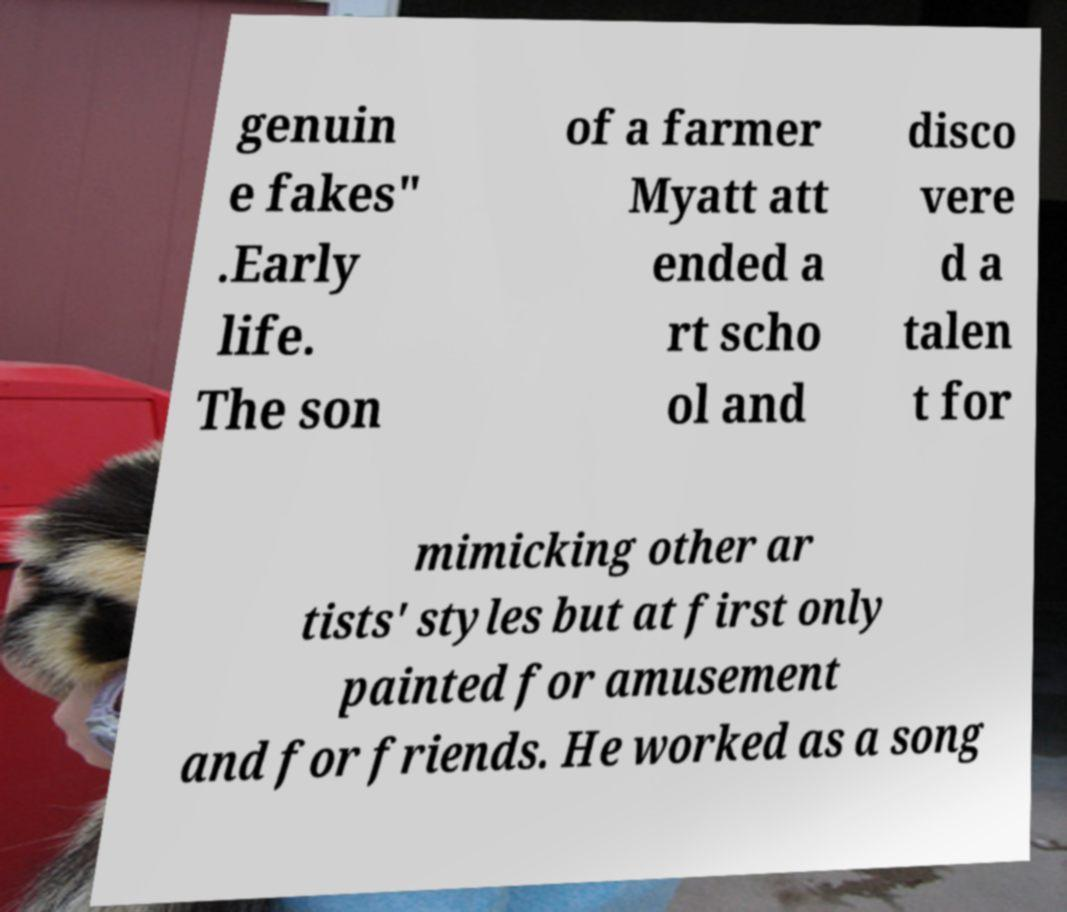Please read and relay the text visible in this image. What does it say? genuin e fakes" .Early life. The son of a farmer Myatt att ended a rt scho ol and disco vere d a talen t for mimicking other ar tists' styles but at first only painted for amusement and for friends. He worked as a song 